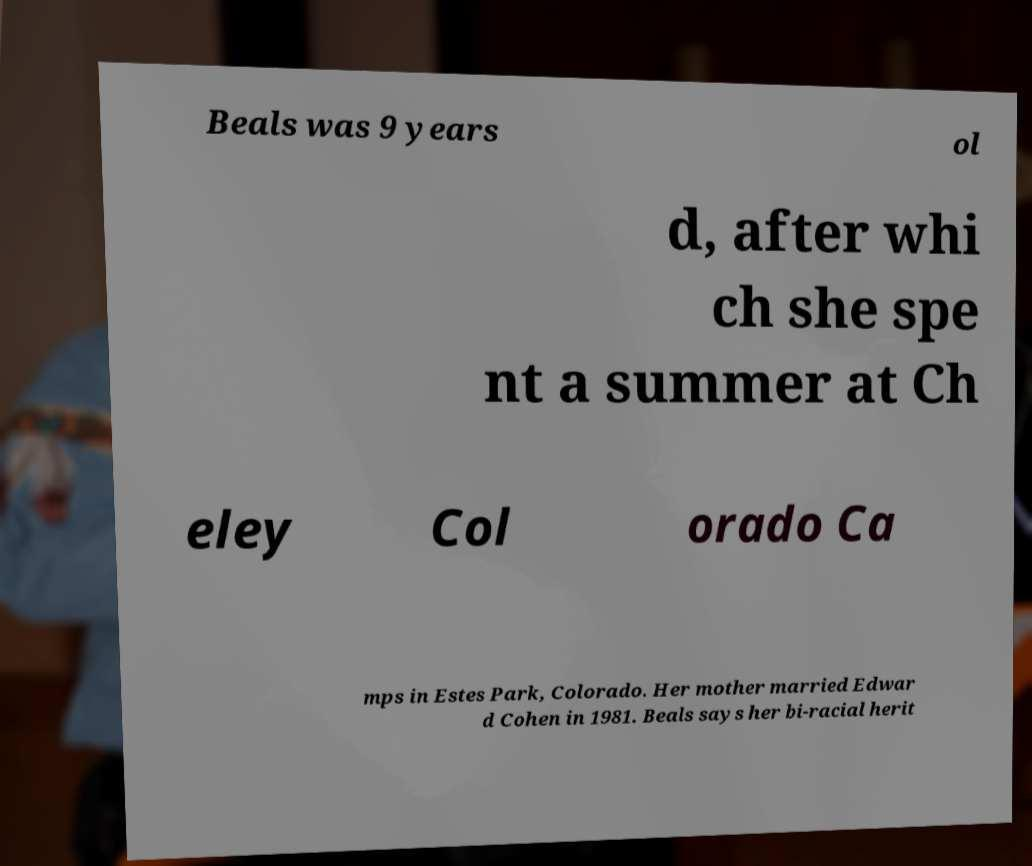Could you assist in decoding the text presented in this image and type it out clearly? Beals was 9 years ol d, after whi ch she spe nt a summer at Ch eley Col orado Ca mps in Estes Park, Colorado. Her mother married Edwar d Cohen in 1981. Beals says her bi-racial herit 